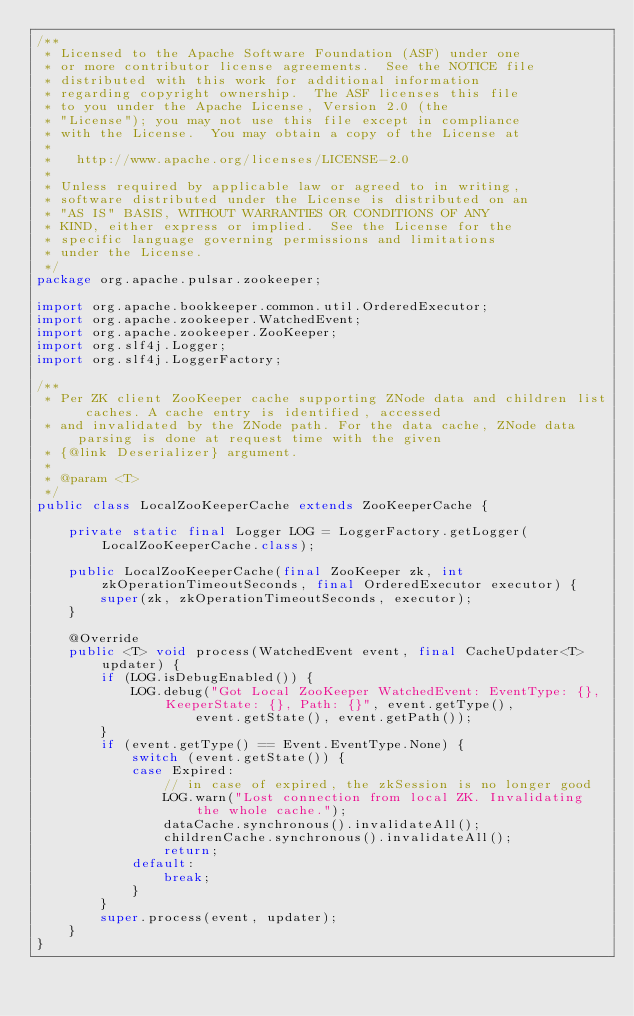<code> <loc_0><loc_0><loc_500><loc_500><_Java_>/**
 * Licensed to the Apache Software Foundation (ASF) under one
 * or more contributor license agreements.  See the NOTICE file
 * distributed with this work for additional information
 * regarding copyright ownership.  The ASF licenses this file
 * to you under the Apache License, Version 2.0 (the
 * "License"); you may not use this file except in compliance
 * with the License.  You may obtain a copy of the License at
 *
 *   http://www.apache.org/licenses/LICENSE-2.0
 *
 * Unless required by applicable law or agreed to in writing,
 * software distributed under the License is distributed on an
 * "AS IS" BASIS, WITHOUT WARRANTIES OR CONDITIONS OF ANY
 * KIND, either express or implied.  See the License for the
 * specific language governing permissions and limitations
 * under the License.
 */
package org.apache.pulsar.zookeeper;

import org.apache.bookkeeper.common.util.OrderedExecutor;
import org.apache.zookeeper.WatchedEvent;
import org.apache.zookeeper.ZooKeeper;
import org.slf4j.Logger;
import org.slf4j.LoggerFactory;

/**
 * Per ZK client ZooKeeper cache supporting ZNode data and children list caches. A cache entry is identified, accessed
 * and invalidated by the ZNode path. For the data cache, ZNode data parsing is done at request time with the given
 * {@link Deserializer} argument.
 *
 * @param <T>
 */
public class LocalZooKeeperCache extends ZooKeeperCache {

    private static final Logger LOG = LoggerFactory.getLogger(LocalZooKeeperCache.class);

    public LocalZooKeeperCache(final ZooKeeper zk, int zkOperationTimeoutSeconds, final OrderedExecutor executor) {
        super(zk, zkOperationTimeoutSeconds, executor);
    }

    @Override
    public <T> void process(WatchedEvent event, final CacheUpdater<T> updater) {
        if (LOG.isDebugEnabled()) {
            LOG.debug("Got Local ZooKeeper WatchedEvent: EventType: {}, KeeperState: {}, Path: {}", event.getType(),
                    event.getState(), event.getPath());
        }
        if (event.getType() == Event.EventType.None) {
            switch (event.getState()) {
            case Expired:
                // in case of expired, the zkSession is no longer good
                LOG.warn("Lost connection from local ZK. Invalidating the whole cache.");
                dataCache.synchronous().invalidateAll();
                childrenCache.synchronous().invalidateAll();
                return;
            default:
                break;
            }
        }
        super.process(event, updater);
    }
}
</code> 